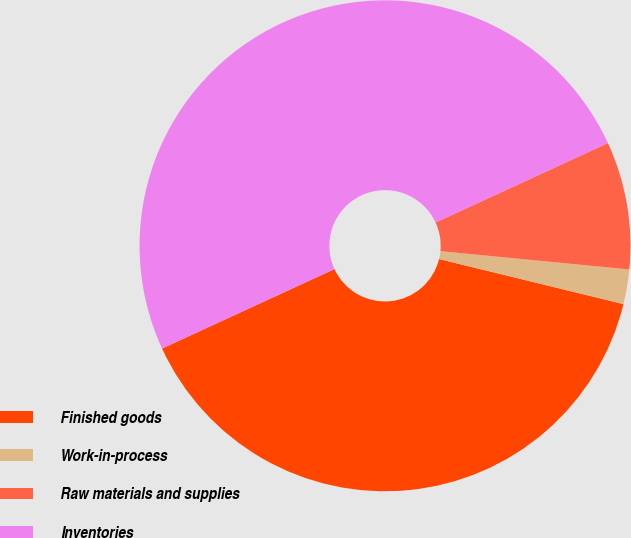Convert chart. <chart><loc_0><loc_0><loc_500><loc_500><pie_chart><fcel>Finished goods<fcel>Work-in-process<fcel>Raw materials and supplies<fcel>Inventories<nl><fcel>39.31%<fcel>2.28%<fcel>8.41%<fcel>50.0%<nl></chart> 